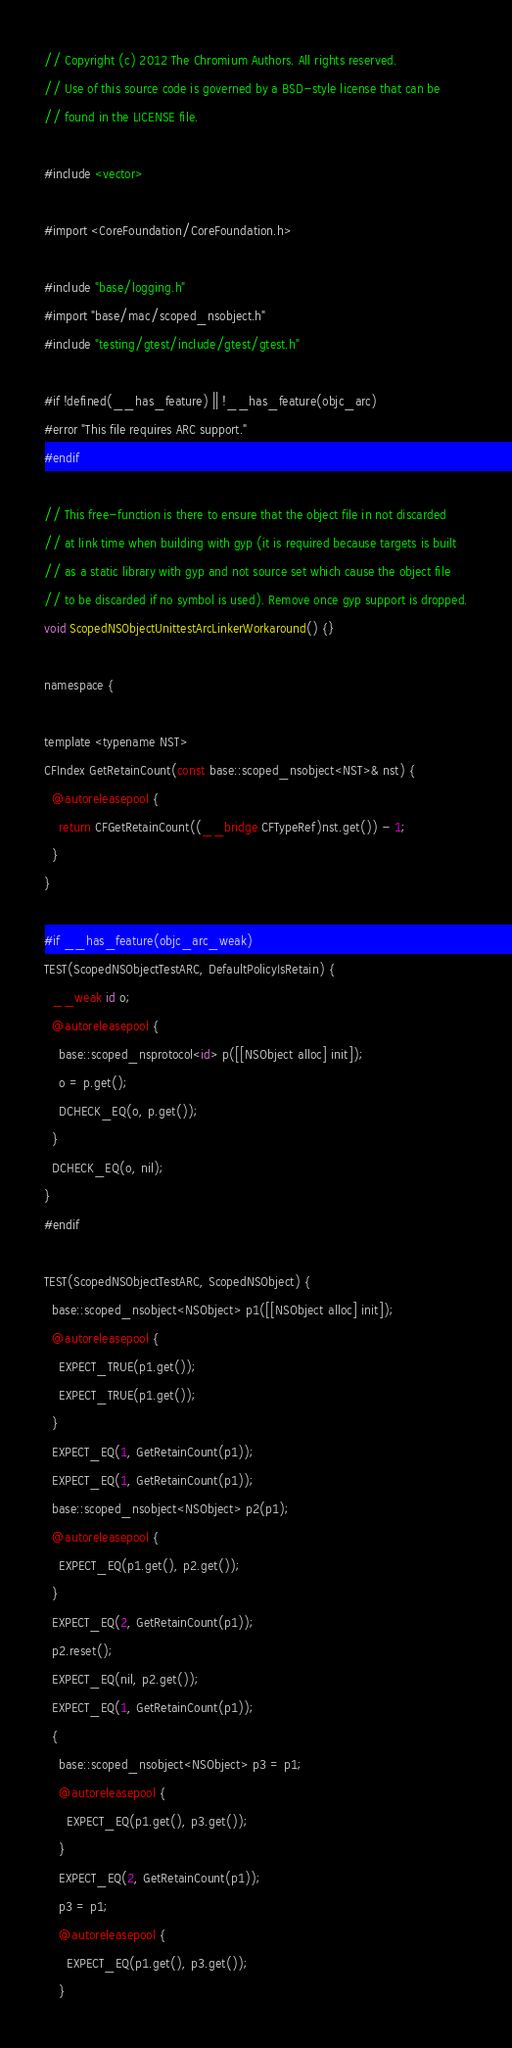Convert code to text. <code><loc_0><loc_0><loc_500><loc_500><_ObjectiveC_>// Copyright (c) 2012 The Chromium Authors. All rights reserved.
// Use of this source code is governed by a BSD-style license that can be
// found in the LICENSE file.

#include <vector>

#import <CoreFoundation/CoreFoundation.h>

#include "base/logging.h"
#import "base/mac/scoped_nsobject.h"
#include "testing/gtest/include/gtest/gtest.h"

#if !defined(__has_feature) || !__has_feature(objc_arc)
#error "This file requires ARC support."
#endif

// This free-function is there to ensure that the object file in not discarded
// at link time when building with gyp (it is required because targets is built
// as a static library with gyp and not source set which cause the object file
// to be discarded if no symbol is used). Remove once gyp support is dropped.
void ScopedNSObjectUnittestArcLinkerWorkaround() {}

namespace {

template <typename NST>
CFIndex GetRetainCount(const base::scoped_nsobject<NST>& nst) {
  @autoreleasepool {
    return CFGetRetainCount((__bridge CFTypeRef)nst.get()) - 1;
  }
}

#if __has_feature(objc_arc_weak)
TEST(ScopedNSObjectTestARC, DefaultPolicyIsRetain) {
  __weak id o;
  @autoreleasepool {
    base::scoped_nsprotocol<id> p([[NSObject alloc] init]);
    o = p.get();
    DCHECK_EQ(o, p.get());
  }
  DCHECK_EQ(o, nil);
}
#endif

TEST(ScopedNSObjectTestARC, ScopedNSObject) {
  base::scoped_nsobject<NSObject> p1([[NSObject alloc] init]);
  @autoreleasepool {
    EXPECT_TRUE(p1.get());
    EXPECT_TRUE(p1.get());
  }
  EXPECT_EQ(1, GetRetainCount(p1));
  EXPECT_EQ(1, GetRetainCount(p1));
  base::scoped_nsobject<NSObject> p2(p1);
  @autoreleasepool {
    EXPECT_EQ(p1.get(), p2.get());
  }
  EXPECT_EQ(2, GetRetainCount(p1));
  p2.reset();
  EXPECT_EQ(nil, p2.get());
  EXPECT_EQ(1, GetRetainCount(p1));
  {
    base::scoped_nsobject<NSObject> p3 = p1;
    @autoreleasepool {
      EXPECT_EQ(p1.get(), p3.get());
    }
    EXPECT_EQ(2, GetRetainCount(p1));
    p3 = p1;
    @autoreleasepool {
      EXPECT_EQ(p1.get(), p3.get());
    }</code> 